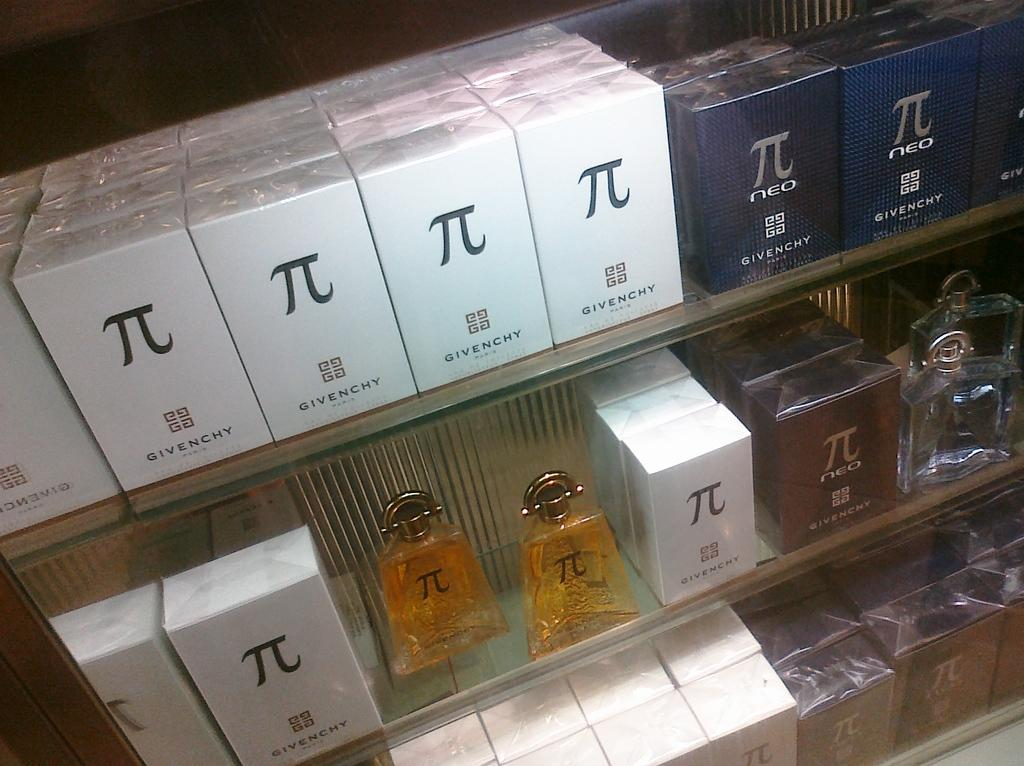<image>
Relay a brief, clear account of the picture shown. Bottles of cologne by Givenchy marked with the symbol for pi. 